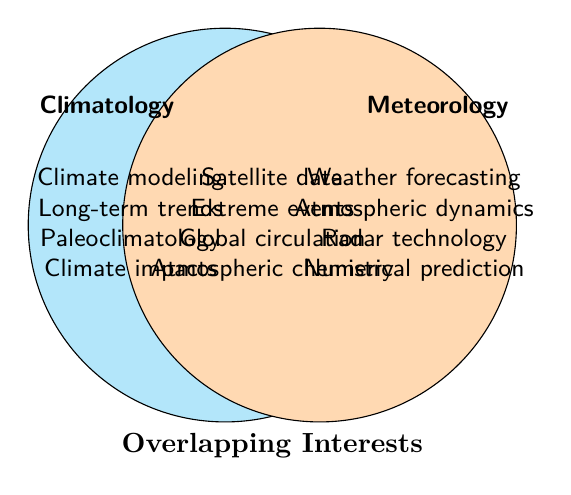What are the overlapping research interests between climatology and meteorology? The section where the two circles intersect represents the overlapping research interests. The items listed there include Satellite data analysis, Extreme weather events, Global circulation patterns, and Atmospheric chemistry.
Answer: Satellite data analysis, Extreme weather events, Global circulation patterns, Atmospheric chemistry Name two topics unique to climatology but not shared with meteorology. Looking at the climatology circle, the unique topics are Climate modeling, Long-term climate trends, Paleoclimatology, and Climate change impacts. Any two of these are correct choices.
Answer: Any two of Climate modeling, Long-term climate trends, Paleoclimatology, Climate change impacts How many distinct topics are associated with meteorology? The meteorology circle, excluding the overlapping section, contains Weather forecasting, Atmospheric dynamics, Radar technology, and Numerical weather prediction. Counting these, we get four distinct topics.
Answer: Four Is there a topic related to both climatology and meteorology involving technology? Reviewing the overlapping section, Satellite data analysis is the only topic that clearly involves technology and is related to both fields.
Answer: Satellite data analysis Which research interest spans both fields and involves studying patterns on a global scale? From the overlapping section, Global circulation patterns is the research interest that deals with studying patterns on a global scale.
Answer: Global circulation patterns Why do Satellite data analysis and Atmospheric chemistry fit within the overlapping region? Both of these topics require an interdisciplinary approach involving both climatology and meteorology to gather and interpret data that affects both climate and weather studies.
Answer: Require interdisciplinary approach Compare the number of unique topics in climatology and meteorology. Which has more? Climatology has four unique topics (Climate modeling, Long-term climate trends, Paleoclimatology, Climate change impacts) while Meteorology also has four (Weather forecasting, Atmospheric dynamics, Radar technology, Numerical weather prediction), meaning they have equal numbers.
Answer: Equal Which topics deal directly with events that might have immediate, noticeable impacts on human activities? Extreme weather events, Global circulation patterns, and Numerical weather prediction are directly related to immediate, noticeable impacts on human activities.
Answer: Extreme weather events, Global circulation patterns, Numerical weather prediction Identify all the topics related to atmospheric studies. Reviewing both the fields and the overlapping section, Atmospheric dynamics, Atmospheric chemistry are the relevant topics directly related to atmospheric studies.
Answer: Atmospheric dynamics, Atmospheric chemistry How does the number of overlapping topics compare to the unique climatology topics? There are four unique climatology topics and four overlapping topics, making them equal in number.
Answer: Equal 